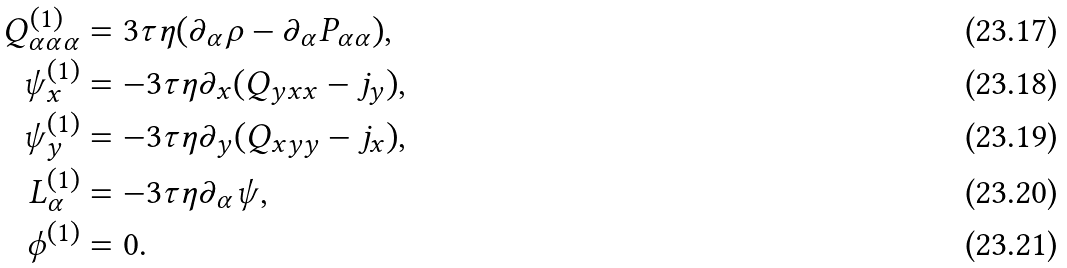Convert formula to latex. <formula><loc_0><loc_0><loc_500><loc_500>Q _ { \alpha \alpha \alpha } ^ { ( 1 ) } & = 3 \tau \eta ( \partial _ { \alpha } \rho - \partial _ { \alpha } P _ { \alpha \alpha } ) , \\ \psi _ { x } ^ { ( 1 ) } & = - 3 \tau \eta \partial _ { x } ( Q _ { y x x } - j _ { y } ) , \\ \psi _ { y } ^ { ( 1 ) } & = - 3 \tau \eta \partial _ { y } ( Q _ { x y y } - j _ { x } ) , \\ L _ { \alpha } ^ { ( 1 ) } & = - 3 \tau \eta \partial _ { \alpha } \psi , \\ \phi ^ { ( 1 ) } & = 0 .</formula> 